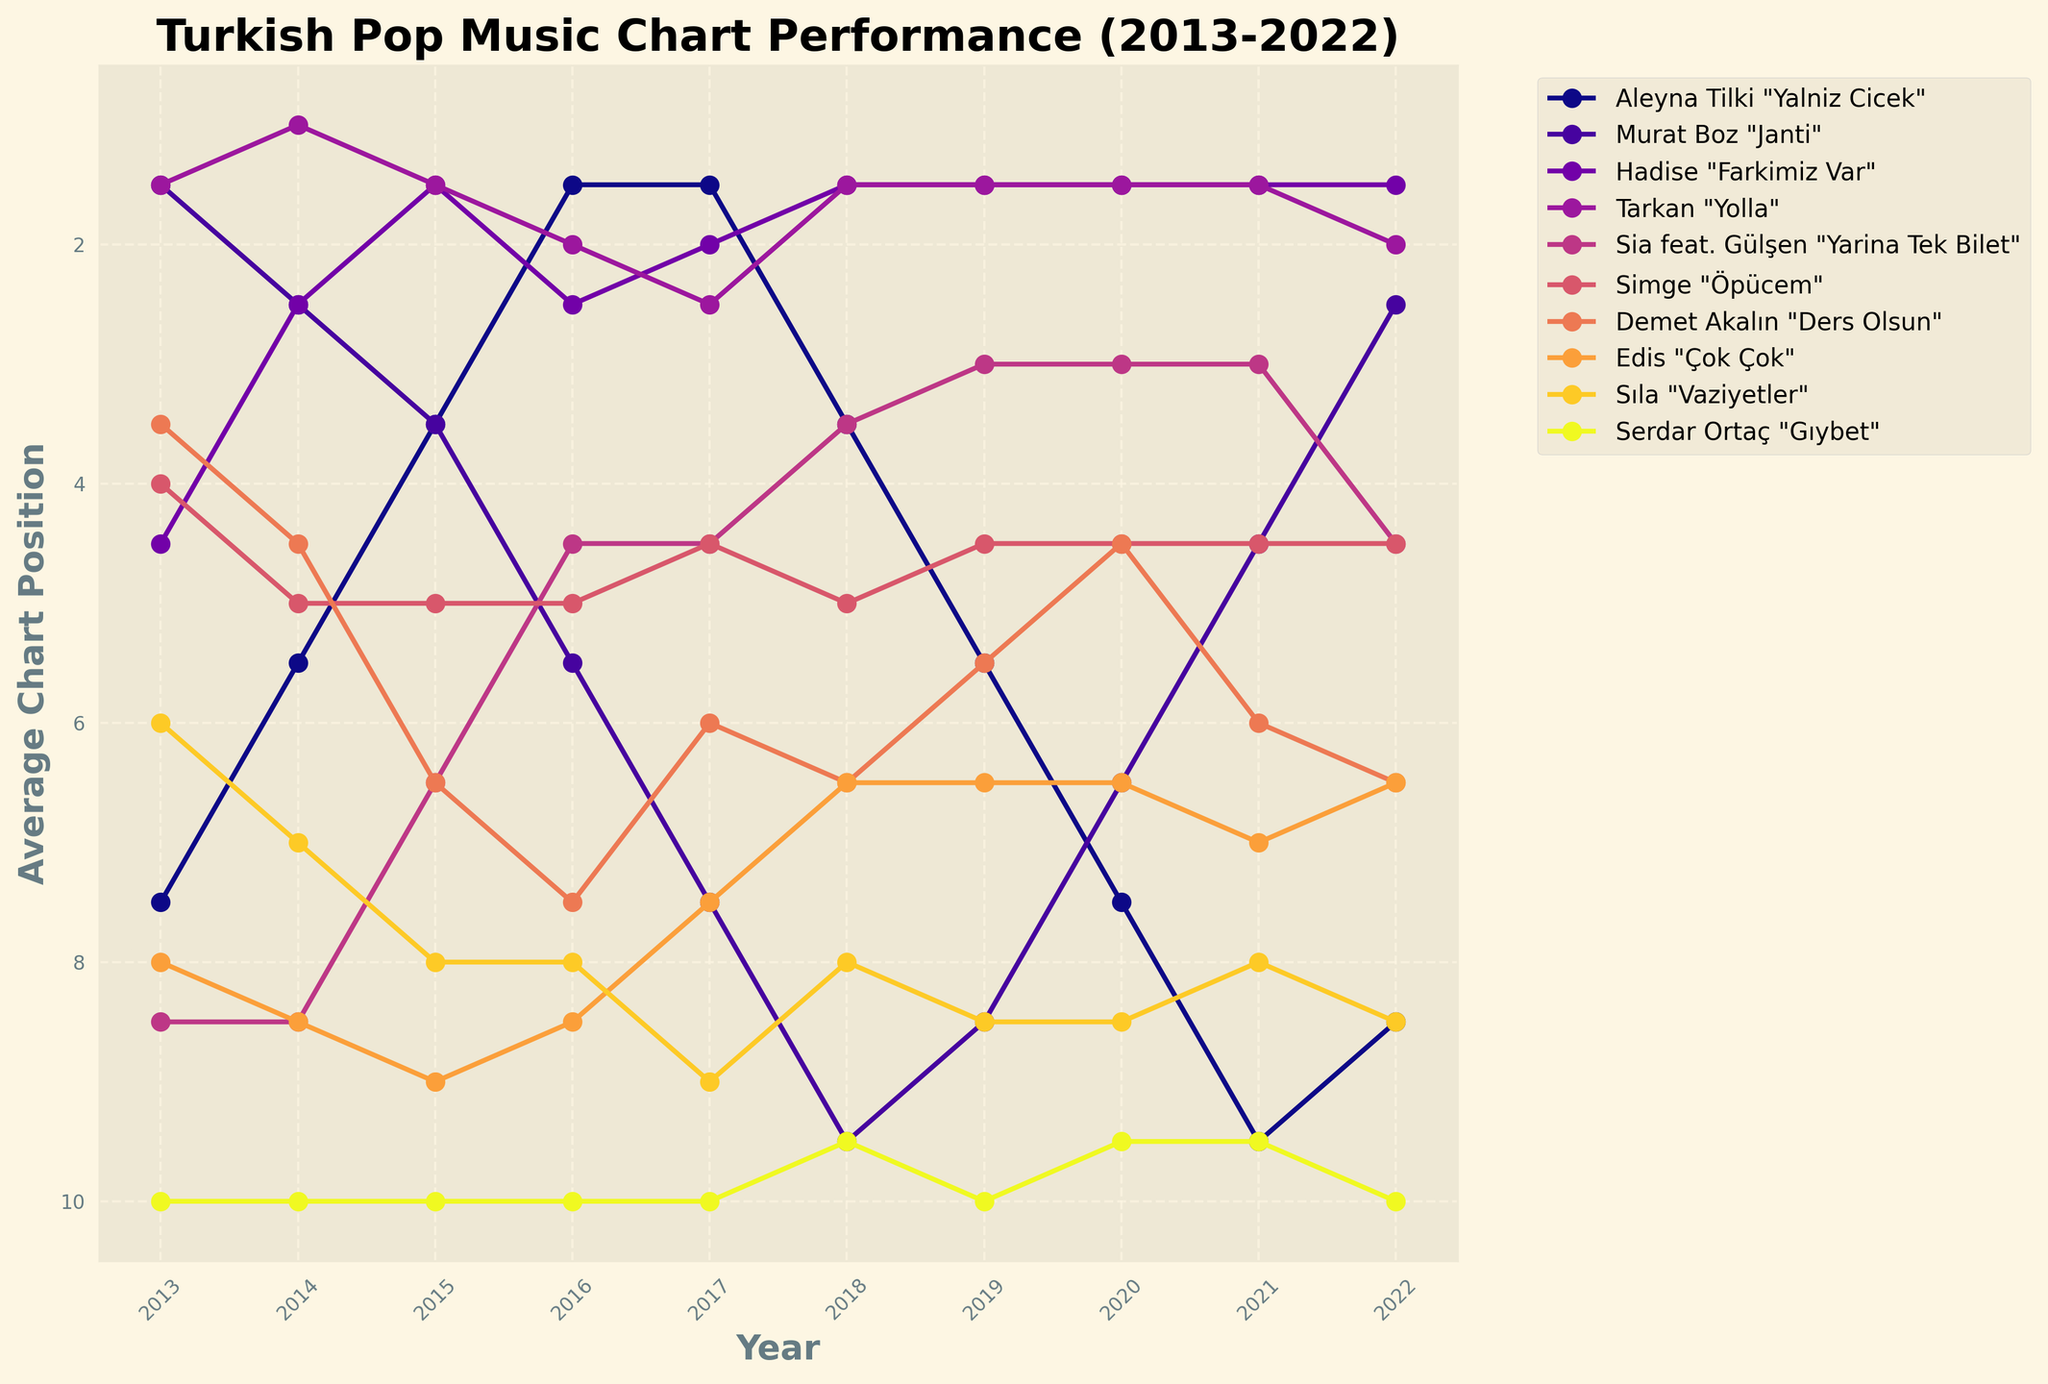what's the average chart position of Aleyna Tilki "Yalniz Cicek" in 2020? To find the average, look at Aleyna Tilki's chart positions for both weeks in 2020 and calculate the average. (7 in week 1 + 8 in week 26) / 2 = 7.5
Answer: 7.5 Which artist has the most consistent chart performance over the years? To determine consistency, find the artist whose line in the graph shows the least fluctuation. Edis "Çok Çok" appears to have a relatively stable average chart position over the years.
Answer: Edis "Çok Çok" In which year does Tarkan "Yolla" achieve its highest average chart position? Look for the lowest points on Tarkan's line in the chart as lower values mean higher positions. In 2014, Tarkan's graph has its lowest average value indicating it was the highest chart position.
Answer: 2014 How does Hadise "Farkimiz Var" chart in the year 2017 compare to its performance in 2022? Compare the positions of Hadise in 2017 and 2022 by observing the data points on the graph or the reduction in the chart positions line. 2017 showed better performance since the average position is lower than in 2022.
Answer: Better in 2017 What's the biggest drop in the average chart position for any song between consecutive years? Find the largest vertical drop (increase in numerical value) between two consecutive years for a single artist. Murat Boz "Janti" experienced a significant drop from 2 in 2014 to 5 in 2015.
Answer: Murat Boz "Janti" How do Aleyna Tilki "Yalniz Cicek" and Demet Akalın "Ders Olsun"'s chart performances in 2016 compare? Check the average chart position for both artists in 2016 by observing their respective points on the line. Aleyna Tilki has a lower average position (higher chart performance) compared to Demet Akalın.
Answer: Aleyna Tilki better Which song achieved the best average chart performance in the year 2019? Look for the song with the lowest point on the vertical axis for the year 2019. Hadise "Farkimiz Var" had the lowest average position indicating the best performance.
Answer: Hadise "Farkimiz Var" 